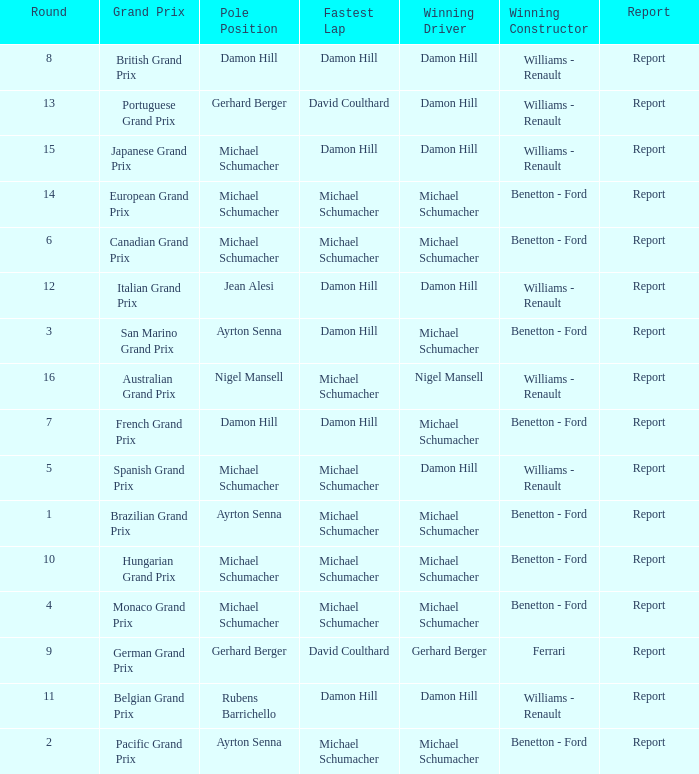Name the lowest round for when pole position and winning driver is michael schumacher 4.0. I'm looking to parse the entire table for insights. Could you assist me with that? {'header': ['Round', 'Grand Prix', 'Pole Position', 'Fastest Lap', 'Winning Driver', 'Winning Constructor', 'Report'], 'rows': [['8', 'British Grand Prix', 'Damon Hill', 'Damon Hill', 'Damon Hill', 'Williams - Renault', 'Report'], ['13', 'Portuguese Grand Prix', 'Gerhard Berger', 'David Coulthard', 'Damon Hill', 'Williams - Renault', 'Report'], ['15', 'Japanese Grand Prix', 'Michael Schumacher', 'Damon Hill', 'Damon Hill', 'Williams - Renault', 'Report'], ['14', 'European Grand Prix', 'Michael Schumacher', 'Michael Schumacher', 'Michael Schumacher', 'Benetton - Ford', 'Report'], ['6', 'Canadian Grand Prix', 'Michael Schumacher', 'Michael Schumacher', 'Michael Schumacher', 'Benetton - Ford', 'Report'], ['12', 'Italian Grand Prix', 'Jean Alesi', 'Damon Hill', 'Damon Hill', 'Williams - Renault', 'Report'], ['3', 'San Marino Grand Prix', 'Ayrton Senna', 'Damon Hill', 'Michael Schumacher', 'Benetton - Ford', 'Report'], ['16', 'Australian Grand Prix', 'Nigel Mansell', 'Michael Schumacher', 'Nigel Mansell', 'Williams - Renault', 'Report'], ['7', 'French Grand Prix', 'Damon Hill', 'Damon Hill', 'Michael Schumacher', 'Benetton - Ford', 'Report'], ['5', 'Spanish Grand Prix', 'Michael Schumacher', 'Michael Schumacher', 'Damon Hill', 'Williams - Renault', 'Report'], ['1', 'Brazilian Grand Prix', 'Ayrton Senna', 'Michael Schumacher', 'Michael Schumacher', 'Benetton - Ford', 'Report'], ['10', 'Hungarian Grand Prix', 'Michael Schumacher', 'Michael Schumacher', 'Michael Schumacher', 'Benetton - Ford', 'Report'], ['4', 'Monaco Grand Prix', 'Michael Schumacher', 'Michael Schumacher', 'Michael Schumacher', 'Benetton - Ford', 'Report'], ['9', 'German Grand Prix', 'Gerhard Berger', 'David Coulthard', 'Gerhard Berger', 'Ferrari', 'Report'], ['11', 'Belgian Grand Prix', 'Rubens Barrichello', 'Damon Hill', 'Damon Hill', 'Williams - Renault', 'Report'], ['2', 'Pacific Grand Prix', 'Ayrton Senna', 'Michael Schumacher', 'Michael Schumacher', 'Benetton - Ford', 'Report']]} 